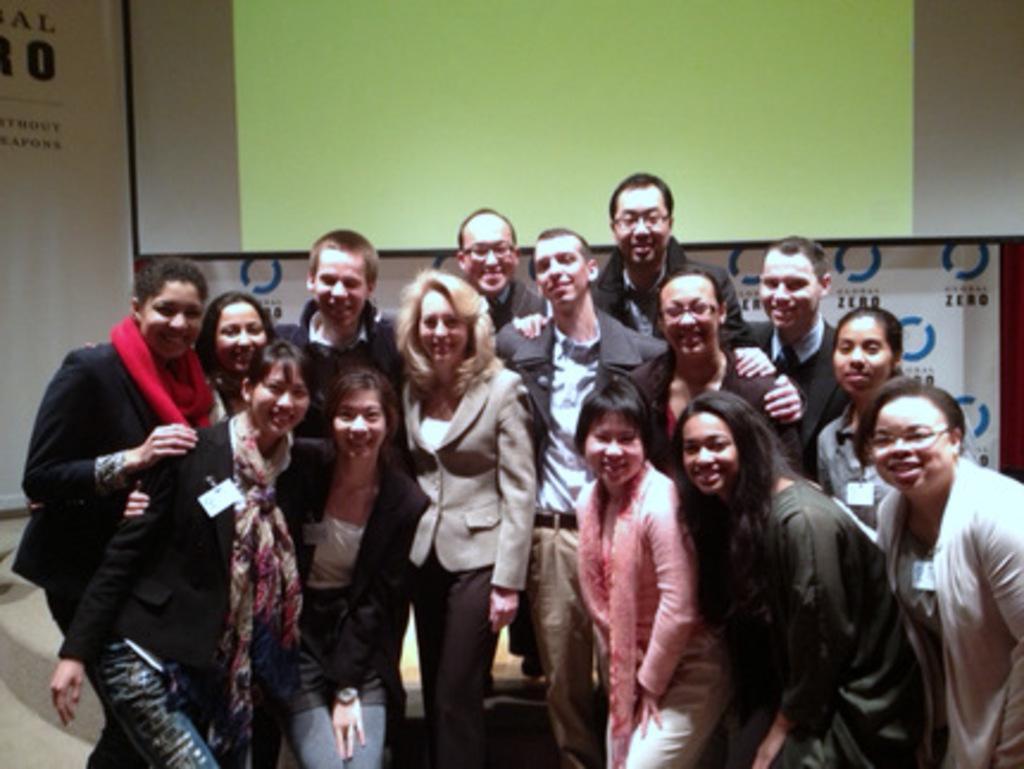In one or two sentences, can you explain what this image depicts? In this picture there are people smiling, behind these people we can see a screen and banners. 